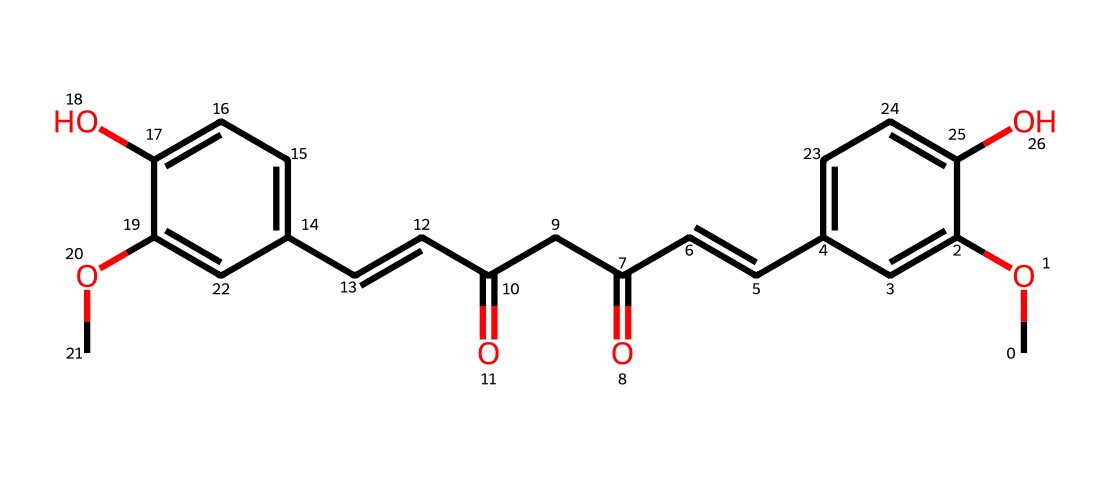What is the molecular formula of curcumin? To determine the molecular formula from the SMILES representation, identify all the unique atoms present in the structure. The primary elements in the provided SMILES are Carbon (C), Hydrogen (H), and Oxygen (O), and counting these gives a molecular formula of C21H20O6.
Answer: C21H20O6 How many hydroxyl (-OH) groups are present in curcumin? By analyzing the structure, the SMILES indicates the presence of two -OH groups on the aromatic ring. Each occurrence of "c(O)" corresponds to a hydroxyl group.
Answer: 2 What is the degree of unsaturation in curcumin? To calculate the degree of unsaturation, use the formula: Degree of Unsaturation = (2C + 2 + N - H - X)/2. In the case of curcumin (21 carbons, 20 hydrogens, 0 nitrogens, and 0 halogens), the calculation gives (2*21 + 2 - 20)/2 = 22/2 = 11, indicating 11 degrees of unsaturation, which accounts for rings and multiple bonds.
Answer: 11 Are there any double bonds in curcumin? The presence of double bonds is indicated by the "/C=C/" notation in the SMILES string, showing that there are multiple carbon-carbon double bonds in the structure.
Answer: yes What type of chemical structure is curcumin classified as? Curcumin is classified as a natural phenolic compound due to the presence of hydroxyl groups (-OH) attached to aromatic rings and the overall structure containing multiple phenolic functionalities.
Answer: phenolic Does curcumin contain any chiral centers? To find chiral centers, look for carbon atoms bonded to four different substituents. In the structure of curcumin, the two carbon atoms at the 2nd position of the α,β-unsaturated carbonyl groups are identified as being connected to different groups, indicating the presence of chiral centers.
Answer: yes What is the role of the methoxy (-OCH3) groups in curcumin? The methoxy groups (-OCH3) contribute to the overall hydrophobicity and stability of the curcumin molecule by providing electron-donating effects to the aromatic system, influencing its biological activity.
Answer: electron-donating 